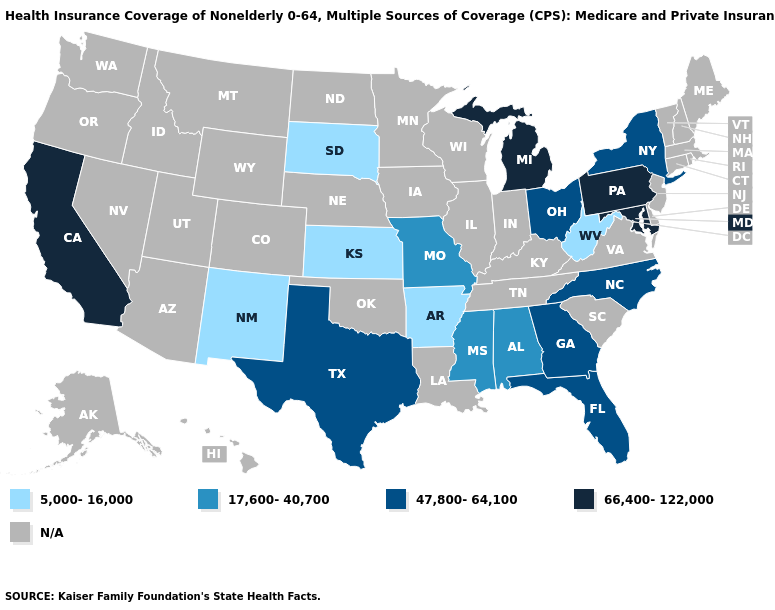What is the lowest value in states that border South Carolina?
Answer briefly. 47,800-64,100. What is the value of Wisconsin?
Quick response, please. N/A. What is the highest value in the USA?
Short answer required. 66,400-122,000. Name the states that have a value in the range 47,800-64,100?
Concise answer only. Florida, Georgia, New York, North Carolina, Ohio, Texas. What is the value of New York?
Answer briefly. 47,800-64,100. What is the highest value in the USA?
Concise answer only. 66,400-122,000. Is the legend a continuous bar?
Answer briefly. No. Does New Mexico have the lowest value in the USA?
Quick response, please. Yes. Which states have the lowest value in the USA?
Concise answer only. Arkansas, Kansas, New Mexico, South Dakota, West Virginia. What is the value of California?
Give a very brief answer. 66,400-122,000. Which states have the highest value in the USA?
Short answer required. California, Maryland, Michigan, Pennsylvania. 